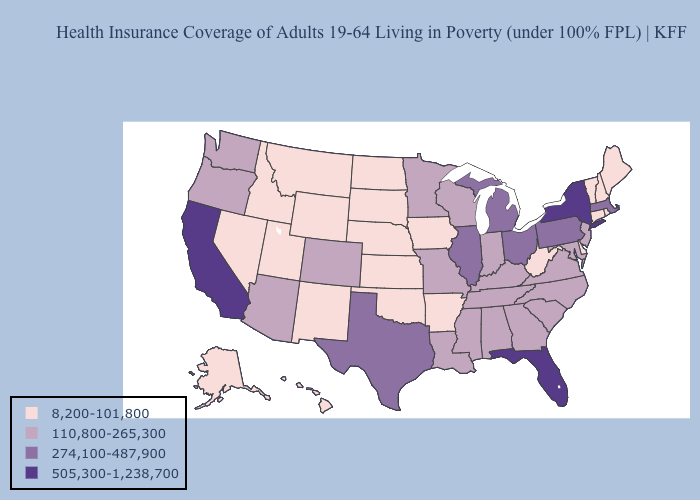Does Florida have the lowest value in the South?
Give a very brief answer. No. Does Florida have the highest value in the South?
Give a very brief answer. Yes. What is the value of Maryland?
Write a very short answer. 110,800-265,300. What is the lowest value in the South?
Give a very brief answer. 8,200-101,800. Name the states that have a value in the range 274,100-487,900?
Write a very short answer. Illinois, Massachusetts, Michigan, Ohio, Pennsylvania, Texas. Name the states that have a value in the range 8,200-101,800?
Keep it brief. Alaska, Arkansas, Connecticut, Delaware, Hawaii, Idaho, Iowa, Kansas, Maine, Montana, Nebraska, Nevada, New Hampshire, New Mexico, North Dakota, Oklahoma, Rhode Island, South Dakota, Utah, Vermont, West Virginia, Wyoming. What is the value of Alabama?
Keep it brief. 110,800-265,300. Does California have the same value as Florida?
Be succinct. Yes. Which states have the lowest value in the USA?
Quick response, please. Alaska, Arkansas, Connecticut, Delaware, Hawaii, Idaho, Iowa, Kansas, Maine, Montana, Nebraska, Nevada, New Hampshire, New Mexico, North Dakota, Oklahoma, Rhode Island, South Dakota, Utah, Vermont, West Virginia, Wyoming. What is the lowest value in states that border Florida?
Be succinct. 110,800-265,300. What is the value of Kentucky?
Keep it brief. 110,800-265,300. What is the value of Florida?
Short answer required. 505,300-1,238,700. What is the value of Texas?
Write a very short answer. 274,100-487,900. What is the highest value in states that border Delaware?
Concise answer only. 274,100-487,900. What is the lowest value in the USA?
Quick response, please. 8,200-101,800. 